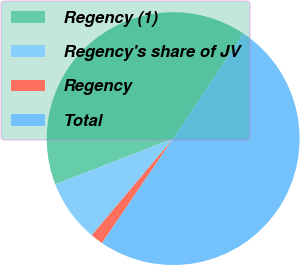<chart> <loc_0><loc_0><loc_500><loc_500><pie_chart><fcel>Regency (1)<fcel>Regency's share of JV<fcel>Regency<fcel>Total<nl><fcel>40.27%<fcel>7.96%<fcel>1.63%<fcel>50.14%<nl></chart> 